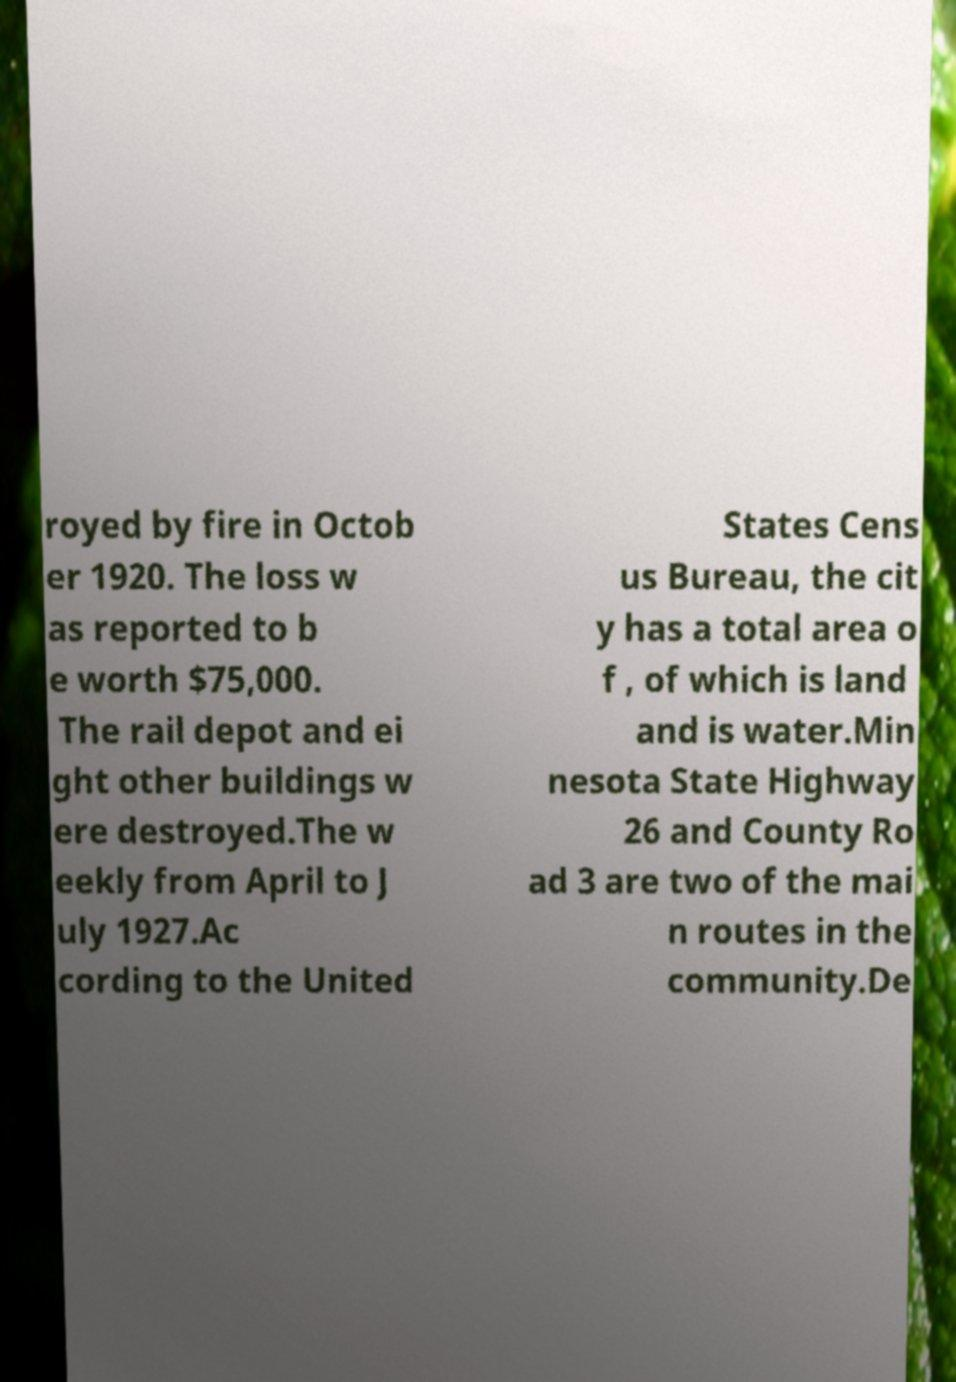Could you assist in decoding the text presented in this image and type it out clearly? royed by fire in Octob er 1920. The loss w as reported to b e worth $75,000. The rail depot and ei ght other buildings w ere destroyed.The w eekly from April to J uly 1927.Ac cording to the United States Cens us Bureau, the cit y has a total area o f , of which is land and is water.Min nesota State Highway 26 and County Ro ad 3 are two of the mai n routes in the community.De 